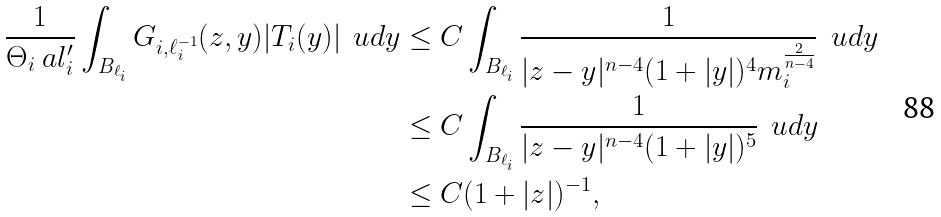<formula> <loc_0><loc_0><loc_500><loc_500>\frac { 1 } { \Theta _ { i } \ a l _ { i } ^ { \prime } } \int _ { B _ { \ell _ { i } } } G _ { i , \ell _ { i } ^ { - 1 } } ( z , y ) | T _ { i } ( y ) | \, \ u d y & \leq C \int _ { B _ { \ell _ { i } } } \frac { 1 } { | z - y | ^ { n - 4 } ( 1 + | y | ) ^ { 4 } m _ { i } ^ { \frac { 2 } { n - 4 } } } \, \ u d y \\ & \leq C \int _ { B _ { \ell _ { i } } } \frac { 1 } { | z - y | ^ { n - 4 } ( 1 + | y | ) ^ { 5 } } \, \ u d y \\ & \leq C ( 1 + | z | ) ^ { - 1 } ,</formula> 